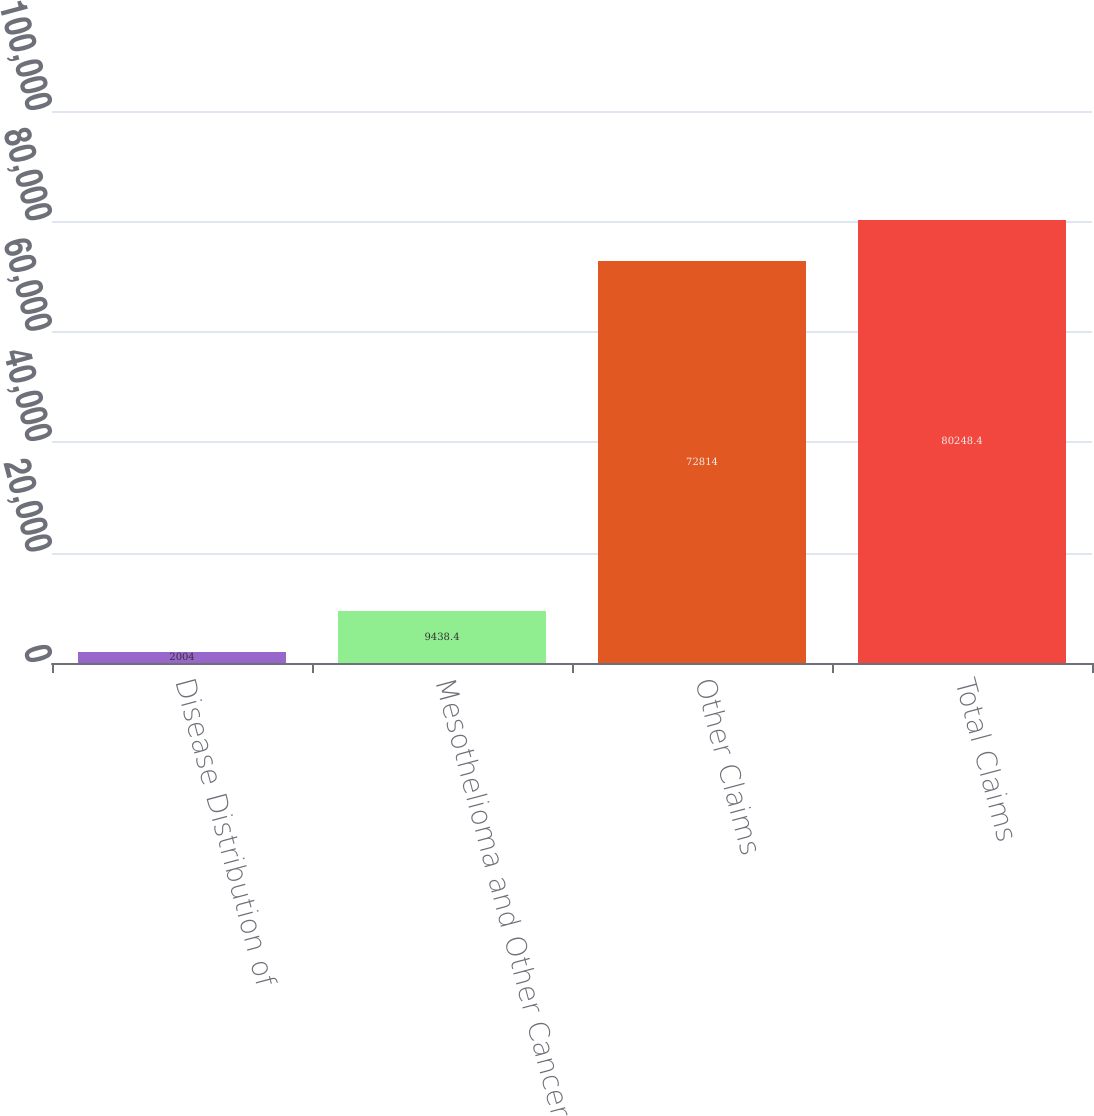Convert chart to OTSL. <chart><loc_0><loc_0><loc_500><loc_500><bar_chart><fcel>Disease Distribution of<fcel>Mesothelioma and Other Cancer<fcel>Other Claims<fcel>Total Claims<nl><fcel>2004<fcel>9438.4<fcel>72814<fcel>80248.4<nl></chart> 